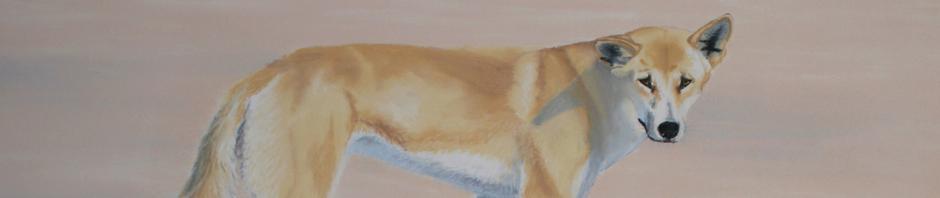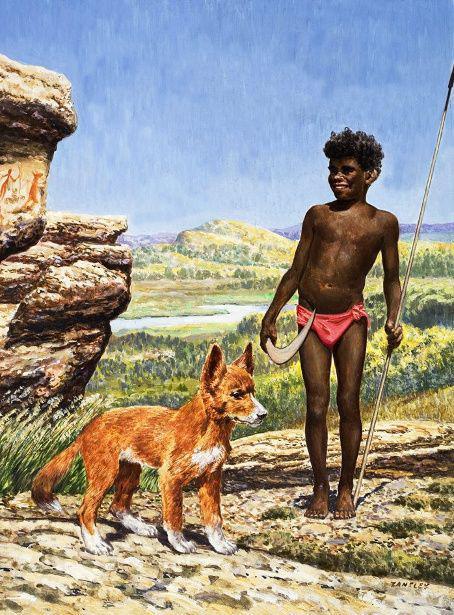The first image is the image on the left, the second image is the image on the right. Evaluate the accuracy of this statement regarding the images: "The right image contains a dog on the beach next to a dead shark.". Is it true? Answer yes or no. No. The first image is the image on the left, the second image is the image on the right. Examine the images to the left and right. Is the description "An image shows a person in some pose to the right of a standing orange dog." accurate? Answer yes or no. Yes. 